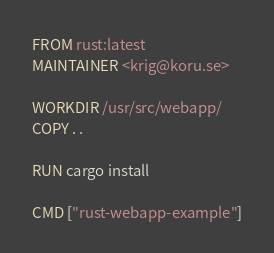Convert code to text. <code><loc_0><loc_0><loc_500><loc_500><_Dockerfile_>FROM rust:latest
MAINTAINER <krig@koru.se>

WORKDIR /usr/src/webapp/
COPY . .

RUN cargo install

CMD ["rust-webapp-example"]
</code> 